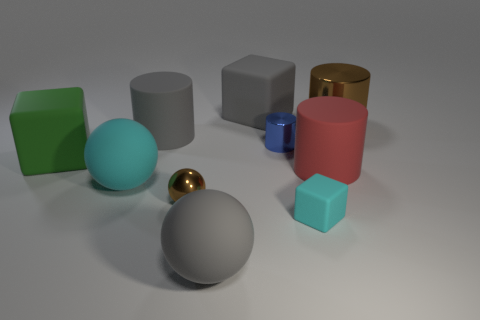The brown object that is on the left side of the cube that is behind the brown thing that is to the right of the tiny cyan rubber cube is what shape?
Make the answer very short. Sphere. The big object that is both in front of the large red rubber thing and on the left side of the brown metal ball has what shape?
Your response must be concise. Sphere. Are there any cyan rubber objects of the same size as the red thing?
Ensure brevity in your answer.  Yes. There is a brown object that is behind the small cylinder; is it the same shape as the tiny brown thing?
Provide a short and direct response. No. Do the large green object and the tiny blue object have the same shape?
Make the answer very short. No. Is there a green rubber object of the same shape as the large red object?
Your answer should be very brief. No. There is a brown shiny object that is behind the green rubber block that is behind the big red cylinder; what is its shape?
Your response must be concise. Cylinder. What is the color of the cylinder that is on the right side of the large red object?
Ensure brevity in your answer.  Brown. What size is the gray block that is made of the same material as the big cyan ball?
Your response must be concise. Large. The gray object that is the same shape as the blue metal object is what size?
Keep it short and to the point. Large. 